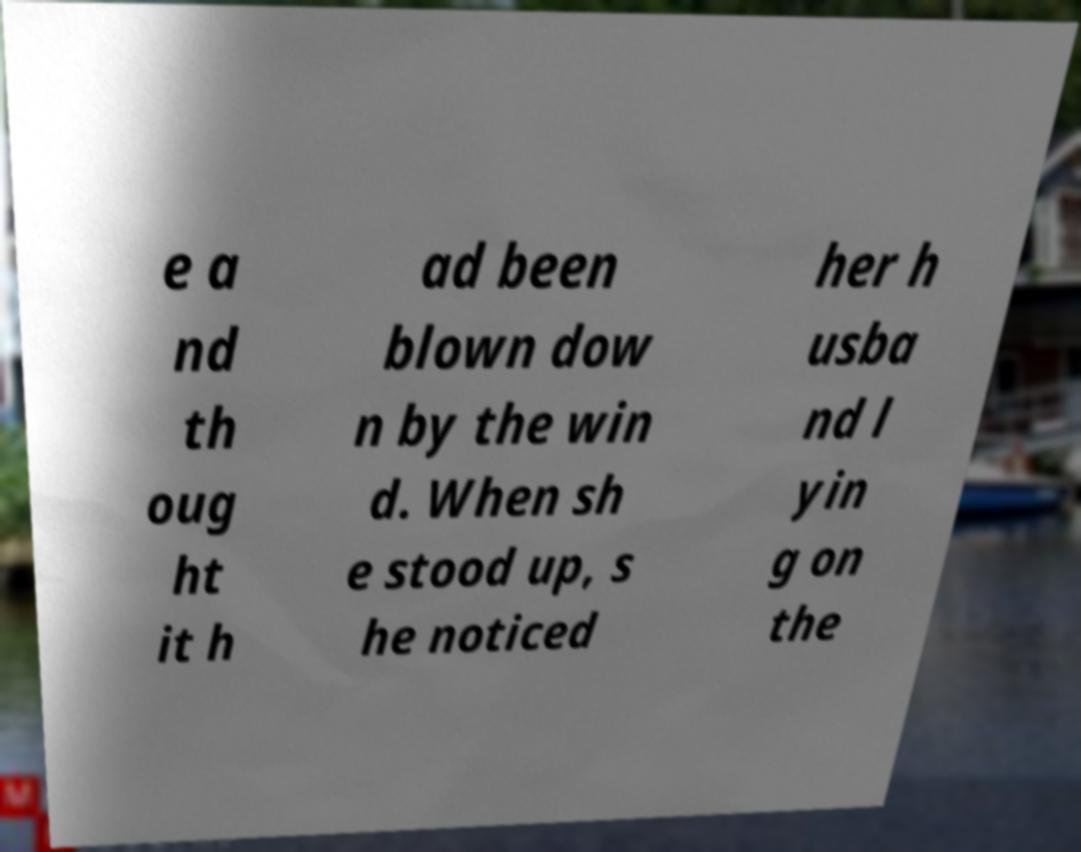Could you extract and type out the text from this image? e a nd th oug ht it h ad been blown dow n by the win d. When sh e stood up, s he noticed her h usba nd l yin g on the 